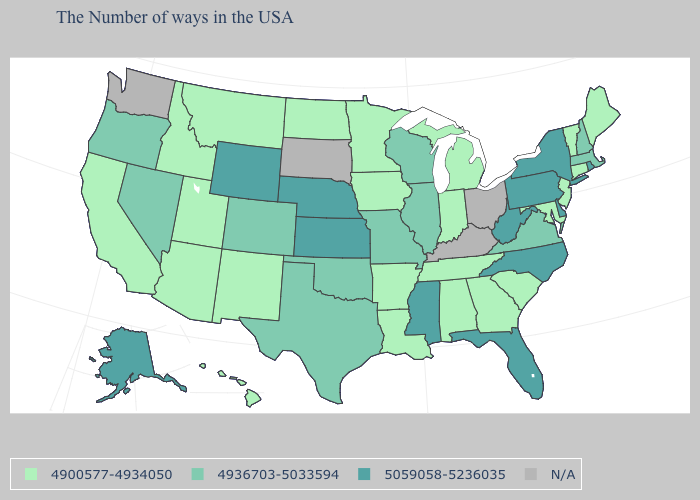What is the value of Louisiana?
Answer briefly. 4900577-4934050. Does the map have missing data?
Be succinct. Yes. What is the value of Washington?
Short answer required. N/A. Is the legend a continuous bar?
Short answer required. No. Name the states that have a value in the range 4936703-5033594?
Give a very brief answer. Massachusetts, New Hampshire, Virginia, Wisconsin, Illinois, Missouri, Oklahoma, Texas, Colorado, Nevada, Oregon. Does Michigan have the highest value in the MidWest?
Answer briefly. No. Name the states that have a value in the range 4900577-4934050?
Quick response, please. Maine, Vermont, Connecticut, New Jersey, Maryland, South Carolina, Georgia, Michigan, Indiana, Alabama, Tennessee, Louisiana, Arkansas, Minnesota, Iowa, North Dakota, New Mexico, Utah, Montana, Arizona, Idaho, California, Hawaii. What is the highest value in states that border Washington?
Answer briefly. 4936703-5033594. What is the highest value in the USA?
Short answer required. 5059058-5236035. What is the value of Tennessee?
Answer briefly. 4900577-4934050. Is the legend a continuous bar?
Write a very short answer. No. Among the states that border Wyoming , which have the highest value?
Quick response, please. Nebraska. What is the value of Florida?
Be succinct. 5059058-5236035. What is the value of Illinois?
Short answer required. 4936703-5033594. What is the value of Washington?
Keep it brief. N/A. 